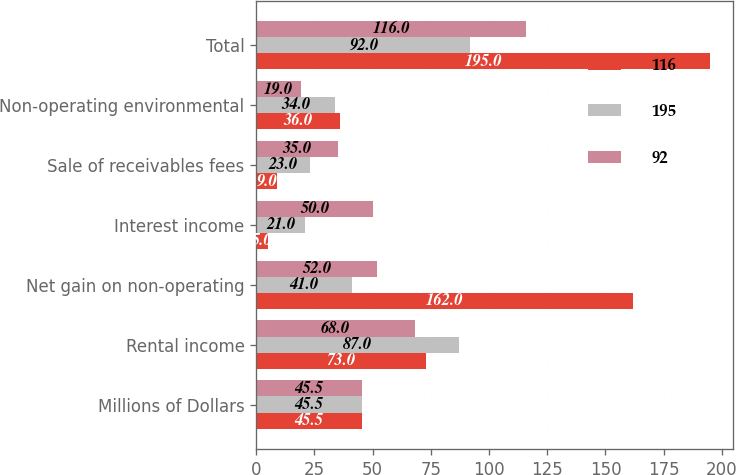Convert chart. <chart><loc_0><loc_0><loc_500><loc_500><stacked_bar_chart><ecel><fcel>Millions of Dollars<fcel>Rental income<fcel>Net gain on non-operating<fcel>Interest income<fcel>Sale of receivables fees<fcel>Non-operating environmental<fcel>Total<nl><fcel>116<fcel>45.5<fcel>73<fcel>162<fcel>5<fcel>9<fcel>36<fcel>195<nl><fcel>195<fcel>45.5<fcel>87<fcel>41<fcel>21<fcel>23<fcel>34<fcel>92<nl><fcel>92<fcel>45.5<fcel>68<fcel>52<fcel>50<fcel>35<fcel>19<fcel>116<nl></chart> 